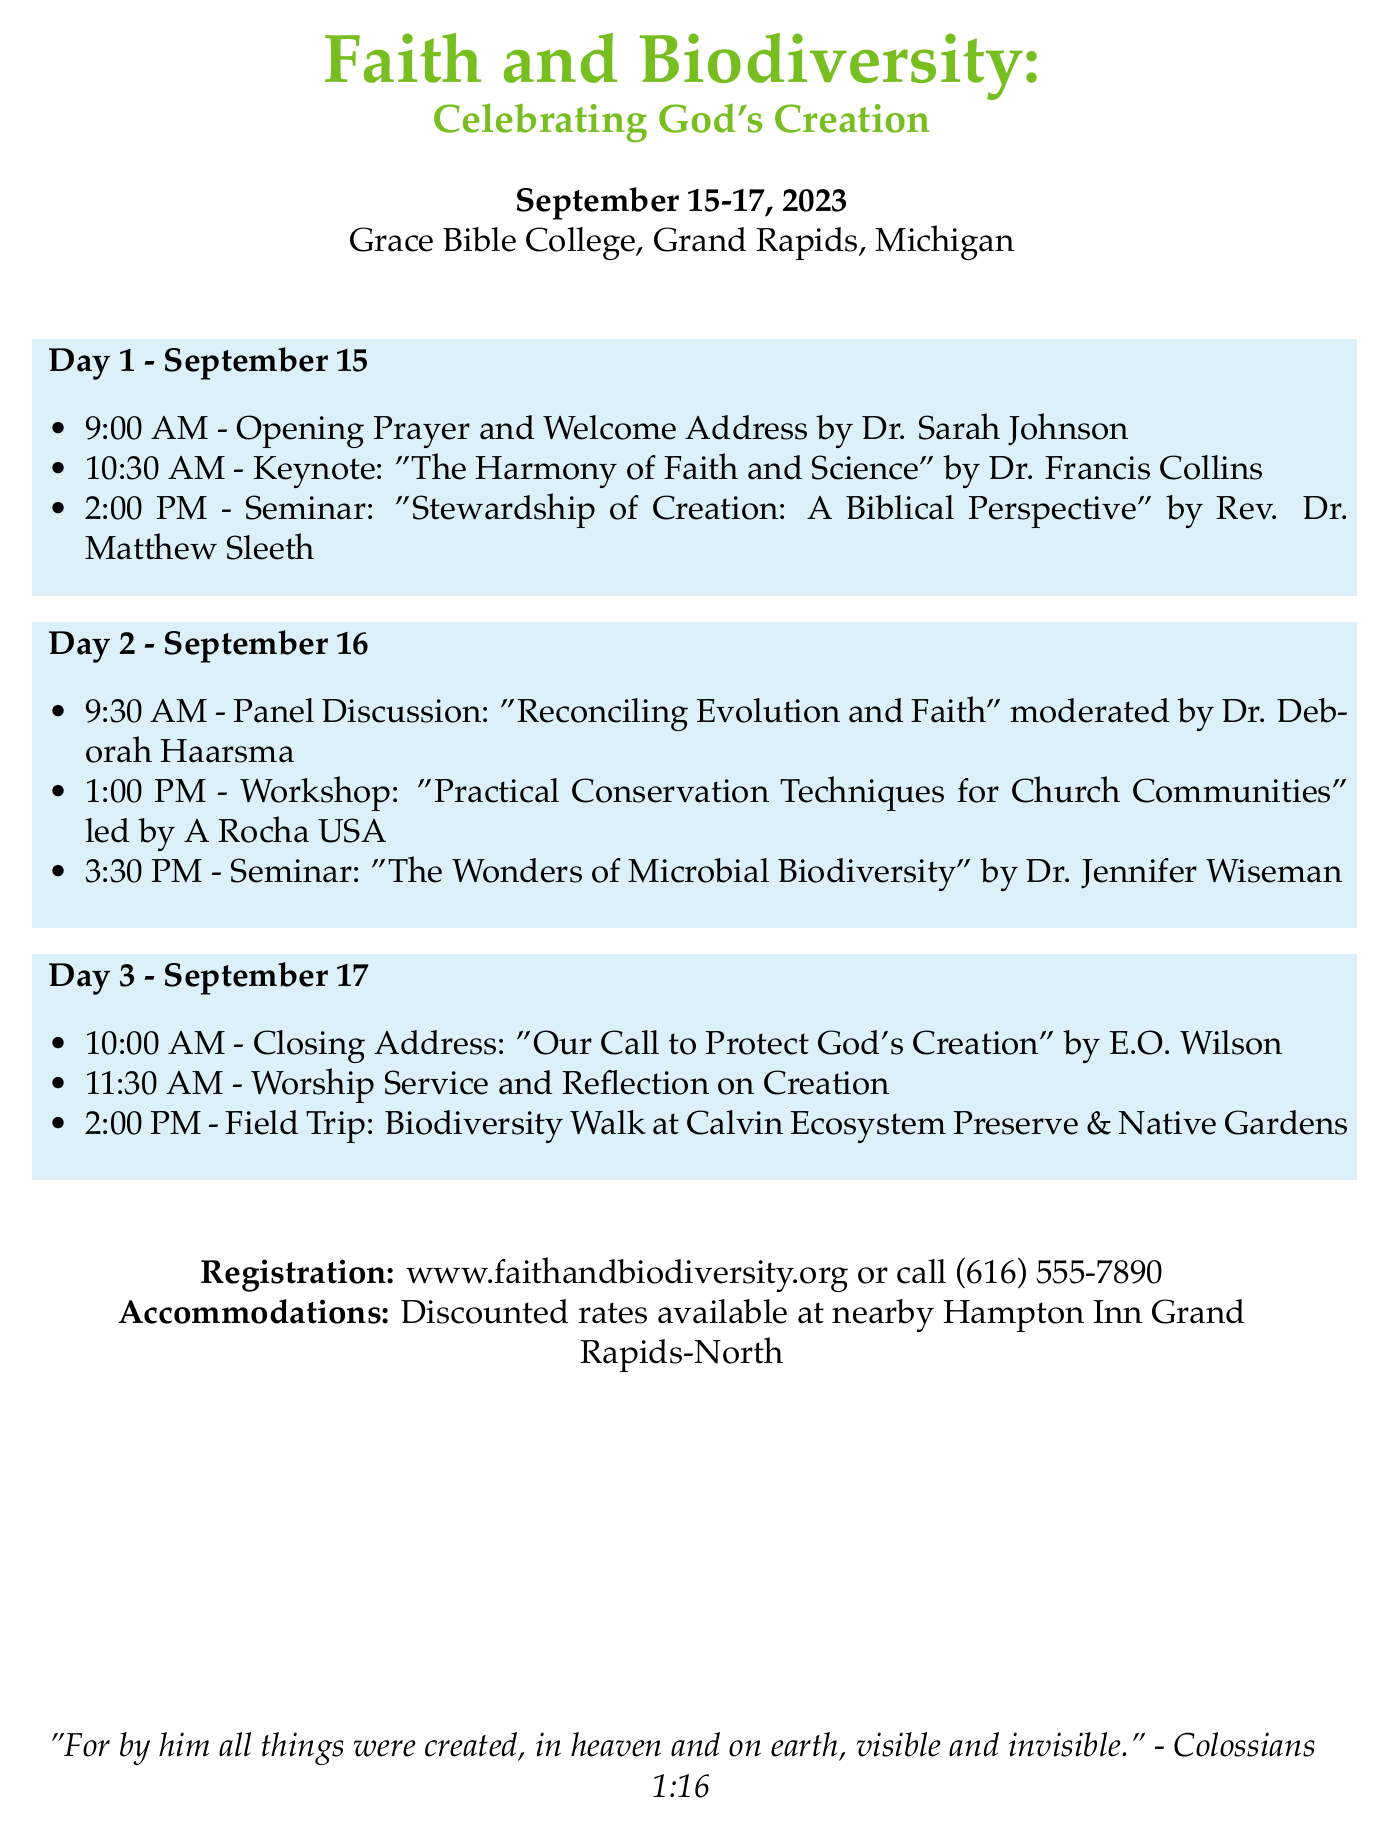What are the dates of the conference? The conference is scheduled for three days from September 15 to September 17, 2023.
Answer: September 15-17, 2023 Who is giving the keynote address? The keynote address is by Dr. Francis Collins, who is specifically mentioned in the schedule for Day 1.
Answer: Dr. Francis Collins What is the topic of the closing address? The closing address is titled "Our Call to Protect God's Creation," as indicated in the Day 3 schedule.
Answer: Our Call to Protect God's Creation What time does Day 2 start? The schedule specifies that Day 2 starts with a panel discussion at 9:30 AM.
Answer: 9:30 AM Which organization is leading the workshop on conservation? The workshop on practical conservation techniques for church communities is led by A Rocha USA.
Answer: A Rocha USA What is the location of the field trip? The field trip on Day 3 is to the Calvin Ecosystem Preserve & Native Gardens, as noted in the schedule.
Answer: Calvin Ecosystem Preserve & Native Gardens What type of event occurs at 11:30 AM on the last day? A worship service and reflection on creation take place at 11:30 AM on Day 3.
Answer: Worship Service and Reflection on Creation What is the website for registration? The document provides a specific website for registration information for the conference.
Answer: www.faithandbiodiversity.org 